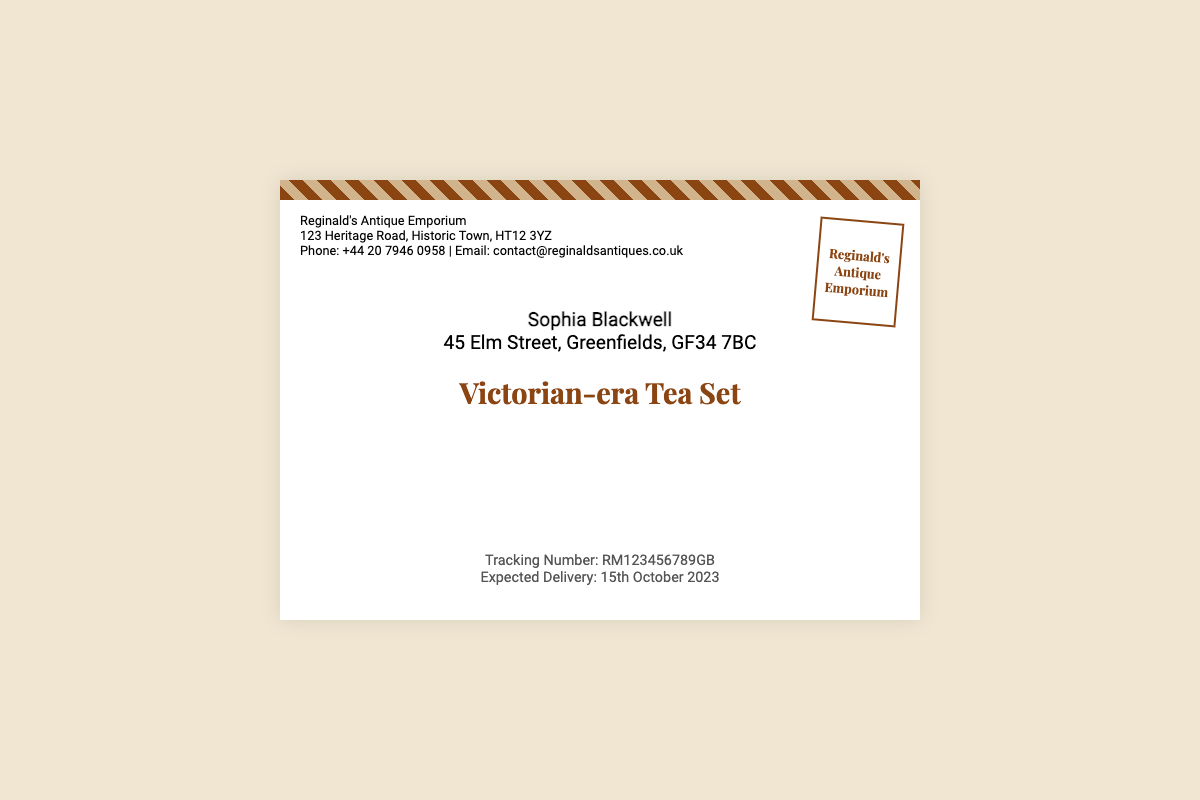What is the sender's name? The sender's name is listed as the first element in the sender's address.
Answer: Reginald's Antique Emporium What is Sophia Blackwell's address? The address of the recipient is mentioned immediately below their name.
Answer: 45 Elm Street, Greenfields, GF34 7BC What is the tracking number? The tracking number is specifically noted in the tracking section of the document.
Answer: RM123456789GB What is the expected delivery date? The expected delivery date is clearly stated in the tracking information.
Answer: 15th October 2023 What type of item is being shipped? The type of item is prominently titled in the center of the envelope.
Answer: Victorian-era Tea Set Where is Reginald's Antique Emporium located? The address is detailed in the sender's information section of the document.
Answer: 123 Heritage Road, Historic Town, HT12 3YZ What is the email contact for Reginald's Antique Emporium? The email is part of the contact details found in the sender's section.
Answer: contact@reginaldsantiques.co.uk Who is the recipient of the tea set? The recipient's name is indicated right below the recipient section title.
Answer: Sophia Blackwell What position is the stamp located? The stamp's position is described in the layout of the document.
Answer: Top right corner 